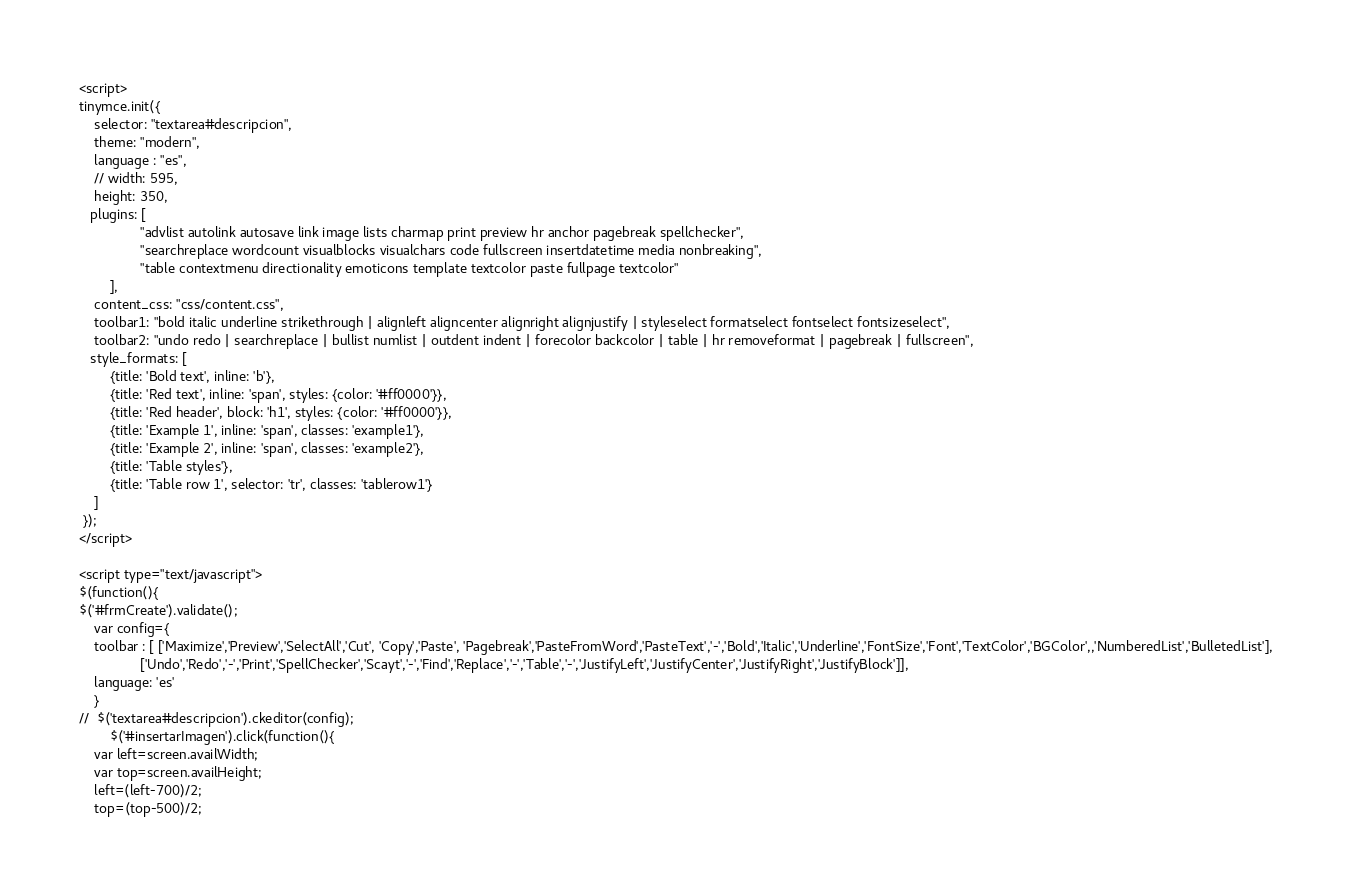<code> <loc_0><loc_0><loc_500><loc_500><_PHP_><script>
tinymce.init({
    selector: "textarea#descripcion",
    theme: "modern",
    language : "es",
    // width: 595,
    height: 350,
   plugins: [
                "advlist autolink autosave link image lists charmap print preview hr anchor pagebreak spellchecker",
                "searchreplace wordcount visualblocks visualchars code fullscreen insertdatetime media nonbreaking",
                "table contextmenu directionality emoticons template textcolor paste fullpage textcolor"
        ],
    content_css: "css/content.css",
    toolbar1: "bold italic underline strikethrough | alignleft aligncenter alignright alignjustify | styleselect formatselect fontselect fontsizeselect",
    toolbar2: "undo redo | searchreplace | bullist numlist | outdent indent | forecolor backcolor | table | hr removeformat | pagebreak | fullscreen",
   style_formats: [
        {title: 'Bold text', inline: 'b'},
        {title: 'Red text', inline: 'span', styles: {color: '#ff0000'}},
        {title: 'Red header', block: 'h1', styles: {color: '#ff0000'}},
        {title: 'Example 1', inline: 'span', classes: 'example1'},
        {title: 'Example 2', inline: 'span', classes: 'example2'},
        {title: 'Table styles'},
        {title: 'Table row 1', selector: 'tr', classes: 'tablerow1'}
    ]
 }); 
</script>

<script type="text/javascript">  
$(function(){
$('#frmCreate').validate();
    var config={
    toolbar : [ ['Maximize','Preview','SelectAll','Cut', 'Copy','Paste', 'Pagebreak','PasteFromWord','PasteText','-','Bold','Italic','Underline','FontSize','Font','TextColor','BGColor',,'NumberedList','BulletedList'],
                ['Undo','Redo','-','Print','SpellChecker','Scayt','-','Find','Replace','-','Table','-','JustifyLeft','JustifyCenter','JustifyRight','JustifyBlock']],
	language: 'es'
    }
//	$('textarea#descripcion').ckeditor(config);
        $('#insertarImagen').click(function(){
	var left=screen.availWidth;
	var top=screen.availHeight;
	left=(left-700)/2;
	top=(top-500)/2;</code> 